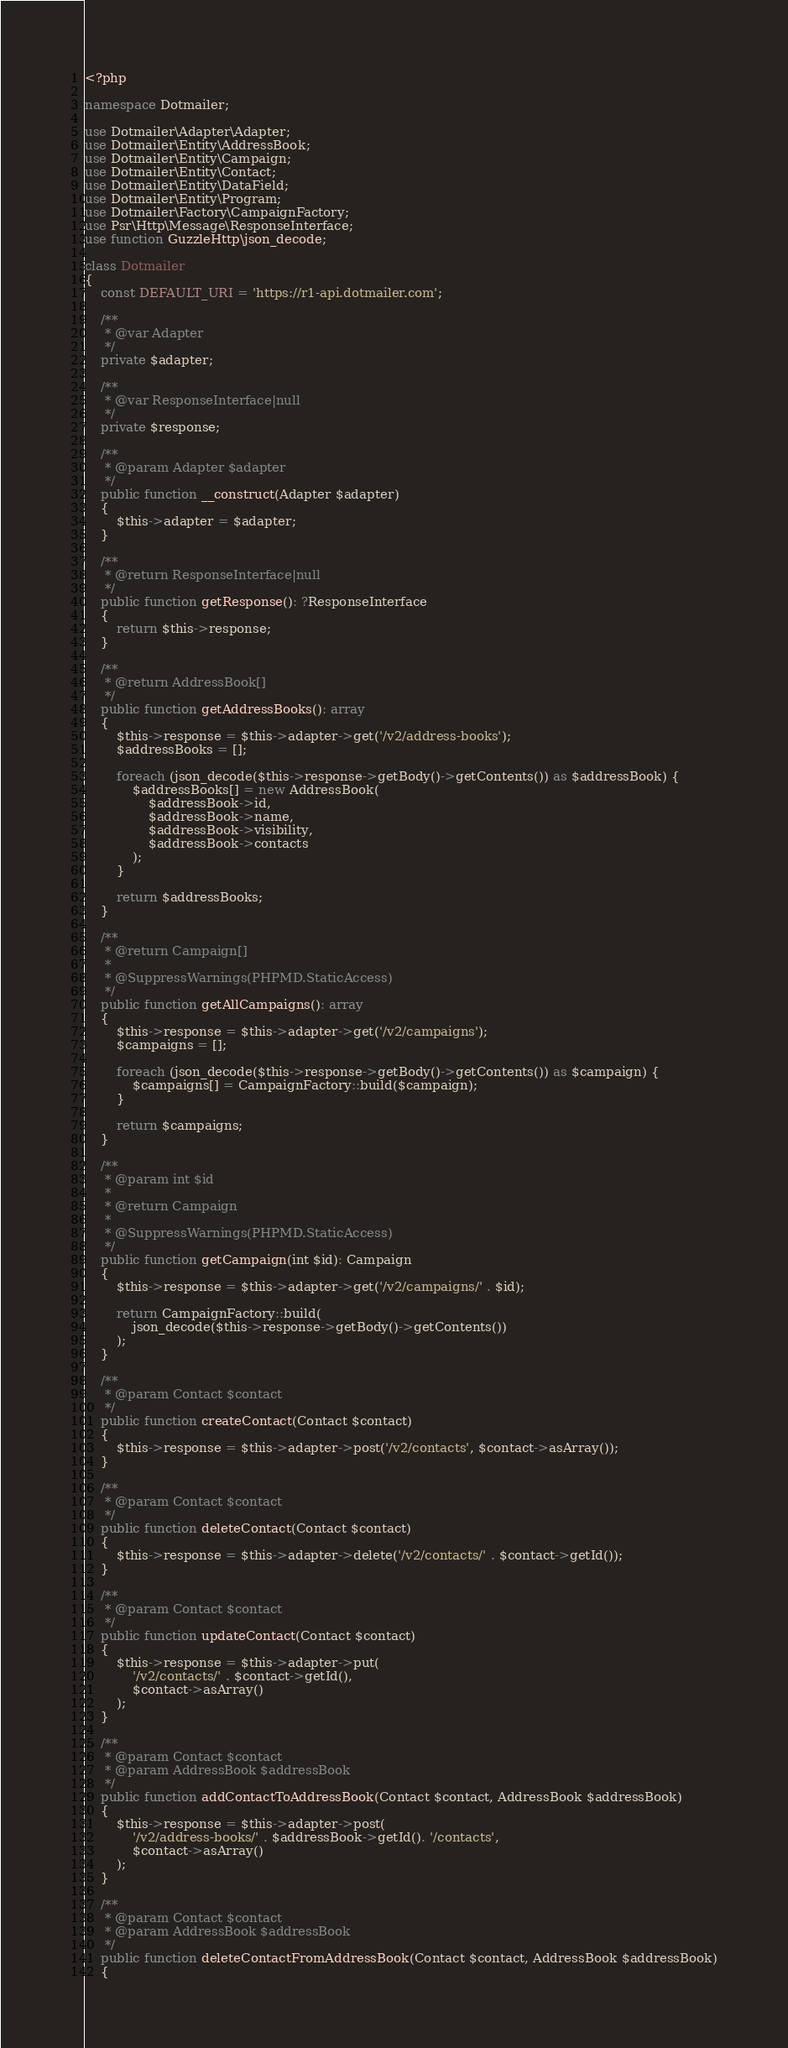Convert code to text. <code><loc_0><loc_0><loc_500><loc_500><_PHP_><?php

namespace Dotmailer;

use Dotmailer\Adapter\Adapter;
use Dotmailer\Entity\AddressBook;
use Dotmailer\Entity\Campaign;
use Dotmailer\Entity\Contact;
use Dotmailer\Entity\DataField;
use Dotmailer\Entity\Program;
use Dotmailer\Factory\CampaignFactory;
use Psr\Http\Message\ResponseInterface;
use function GuzzleHttp\json_decode;

class Dotmailer
{
    const DEFAULT_URI = 'https://r1-api.dotmailer.com';

    /**
     * @var Adapter
     */
    private $adapter;

    /**
     * @var ResponseInterface|null
     */
    private $response;

    /**
     * @param Adapter $adapter
     */
    public function __construct(Adapter $adapter)
    {
        $this->adapter = $adapter;
    }

    /**
     * @return ResponseInterface|null
     */
    public function getResponse(): ?ResponseInterface
    {
        return $this->response;
    }

    /**
     * @return AddressBook[]
     */
    public function getAddressBooks(): array
    {
        $this->response = $this->adapter->get('/v2/address-books');
        $addressBooks = [];

        foreach (json_decode($this->response->getBody()->getContents()) as $addressBook) {
            $addressBooks[] = new AddressBook(
                $addressBook->id,
                $addressBook->name,
                $addressBook->visibility,
                $addressBook->contacts
            );
        }

        return $addressBooks;
    }

    /**
     * @return Campaign[]
     *
     * @SuppressWarnings(PHPMD.StaticAccess)
     */
    public function getAllCampaigns(): array
    {
        $this->response = $this->adapter->get('/v2/campaigns');
        $campaigns = [];

        foreach (json_decode($this->response->getBody()->getContents()) as $campaign) {
            $campaigns[] = CampaignFactory::build($campaign);
        }

        return $campaigns;
    }

    /**
     * @param int $id
     *
     * @return Campaign
     *
     * @SuppressWarnings(PHPMD.StaticAccess)
     */
    public function getCampaign(int $id): Campaign
    {
        $this->response = $this->adapter->get('/v2/campaigns/' . $id);

        return CampaignFactory::build(
            json_decode($this->response->getBody()->getContents())
        );
    }

    /**
     * @param Contact $contact
     */
    public function createContact(Contact $contact)
    {
        $this->response = $this->adapter->post('/v2/contacts', $contact->asArray());
    }

    /**
     * @param Contact $contact
     */
    public function deleteContact(Contact $contact)
    {
        $this->response = $this->adapter->delete('/v2/contacts/' . $contact->getId());
    }

    /**
     * @param Contact $contact
     */
    public function updateContact(Contact $contact)
    {
        $this->response = $this->adapter->put(
            '/v2/contacts/' . $contact->getId(),
            $contact->asArray()
        );
    }

    /**
     * @param Contact $contact
     * @param AddressBook $addressBook
     */
    public function addContactToAddressBook(Contact $contact, AddressBook $addressBook)
    {
        $this->response = $this->adapter->post(
            '/v2/address-books/' . $addressBook->getId(). '/contacts',
            $contact->asArray()
        );
    }

    /**
     * @param Contact $contact
     * @param AddressBook $addressBook
     */
    public function deleteContactFromAddressBook(Contact $contact, AddressBook $addressBook)
    {</code> 